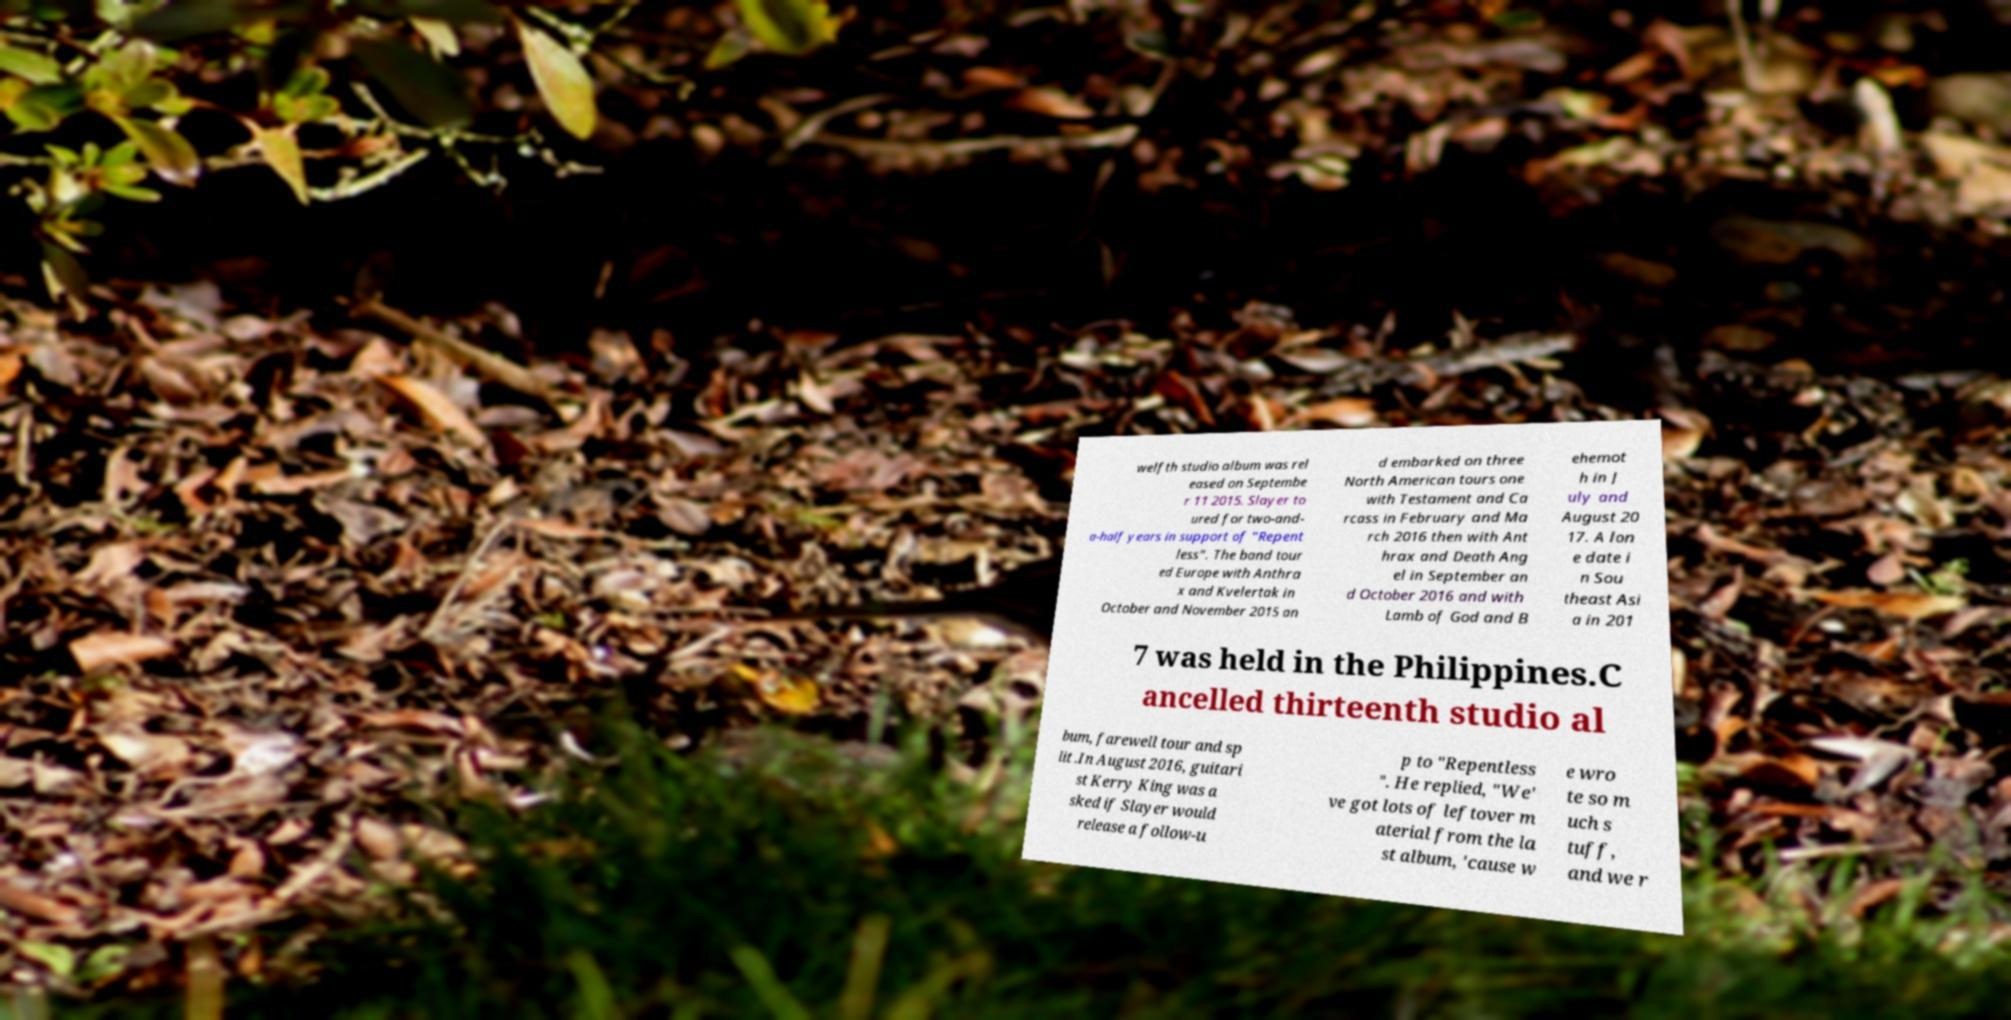Can you read and provide the text displayed in the image?This photo seems to have some interesting text. Can you extract and type it out for me? welfth studio album was rel eased on Septembe r 11 2015. Slayer to ured for two-and- a-half years in support of "Repent less". The band tour ed Europe with Anthra x and Kvelertak in October and November 2015 an d embarked on three North American tours one with Testament and Ca rcass in February and Ma rch 2016 then with Ant hrax and Death Ang el in September an d October 2016 and with Lamb of God and B ehemot h in J uly and August 20 17. A lon e date i n Sou theast Asi a in 201 7 was held in the Philippines.C ancelled thirteenth studio al bum, farewell tour and sp lit .In August 2016, guitari st Kerry King was a sked if Slayer would release a follow-u p to "Repentless ". He replied, "We' ve got lots of leftover m aterial from the la st album, 'cause w e wro te so m uch s tuff, and we r 